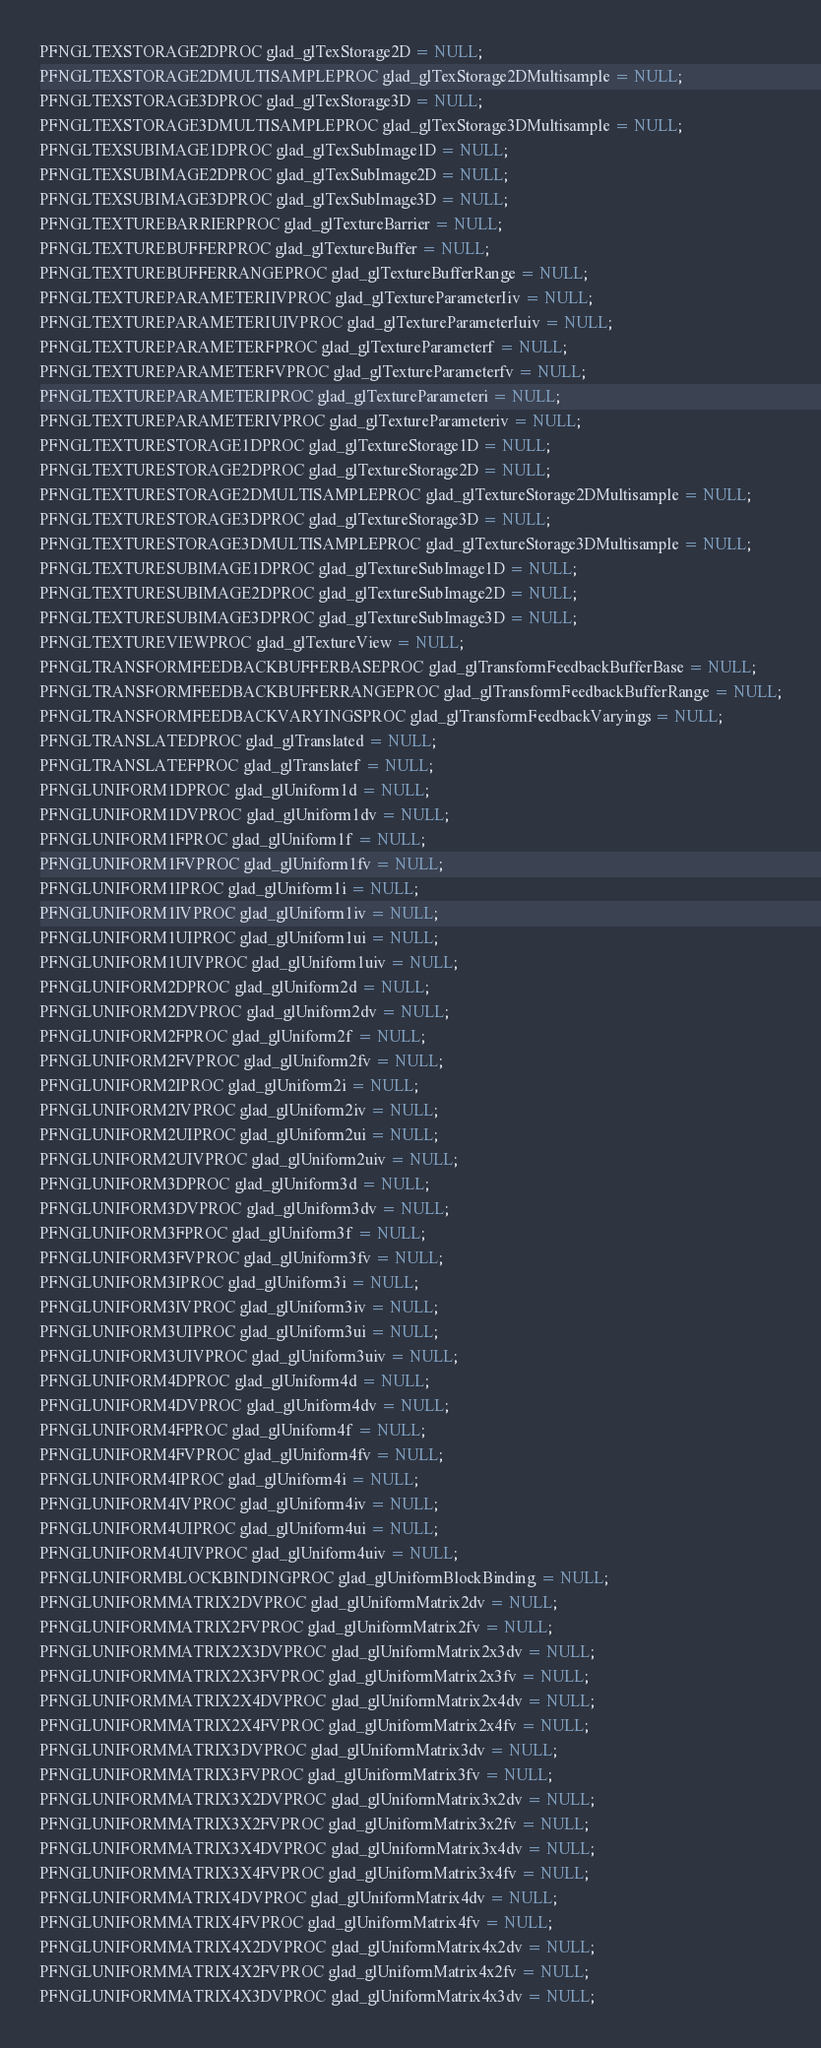<code> <loc_0><loc_0><loc_500><loc_500><_C_>PFNGLTEXSTORAGE2DPROC glad_glTexStorage2D = NULL;
PFNGLTEXSTORAGE2DMULTISAMPLEPROC glad_glTexStorage2DMultisample = NULL;
PFNGLTEXSTORAGE3DPROC glad_glTexStorage3D = NULL;
PFNGLTEXSTORAGE3DMULTISAMPLEPROC glad_glTexStorage3DMultisample = NULL;
PFNGLTEXSUBIMAGE1DPROC glad_glTexSubImage1D = NULL;
PFNGLTEXSUBIMAGE2DPROC glad_glTexSubImage2D = NULL;
PFNGLTEXSUBIMAGE3DPROC glad_glTexSubImage3D = NULL;
PFNGLTEXTUREBARRIERPROC glad_glTextureBarrier = NULL;
PFNGLTEXTUREBUFFERPROC glad_glTextureBuffer = NULL;
PFNGLTEXTUREBUFFERRANGEPROC glad_glTextureBufferRange = NULL;
PFNGLTEXTUREPARAMETERIIVPROC glad_glTextureParameterIiv = NULL;
PFNGLTEXTUREPARAMETERIUIVPROC glad_glTextureParameterIuiv = NULL;
PFNGLTEXTUREPARAMETERFPROC glad_glTextureParameterf = NULL;
PFNGLTEXTUREPARAMETERFVPROC glad_glTextureParameterfv = NULL;
PFNGLTEXTUREPARAMETERIPROC glad_glTextureParameteri = NULL;
PFNGLTEXTUREPARAMETERIVPROC glad_glTextureParameteriv = NULL;
PFNGLTEXTURESTORAGE1DPROC glad_glTextureStorage1D = NULL;
PFNGLTEXTURESTORAGE2DPROC glad_glTextureStorage2D = NULL;
PFNGLTEXTURESTORAGE2DMULTISAMPLEPROC glad_glTextureStorage2DMultisample = NULL;
PFNGLTEXTURESTORAGE3DPROC glad_glTextureStorage3D = NULL;
PFNGLTEXTURESTORAGE3DMULTISAMPLEPROC glad_glTextureStorage3DMultisample = NULL;
PFNGLTEXTURESUBIMAGE1DPROC glad_glTextureSubImage1D = NULL;
PFNGLTEXTURESUBIMAGE2DPROC glad_glTextureSubImage2D = NULL;
PFNGLTEXTURESUBIMAGE3DPROC glad_glTextureSubImage3D = NULL;
PFNGLTEXTUREVIEWPROC glad_glTextureView = NULL;
PFNGLTRANSFORMFEEDBACKBUFFERBASEPROC glad_glTransformFeedbackBufferBase = NULL;
PFNGLTRANSFORMFEEDBACKBUFFERRANGEPROC glad_glTransformFeedbackBufferRange = NULL;
PFNGLTRANSFORMFEEDBACKVARYINGSPROC glad_glTransformFeedbackVaryings = NULL;
PFNGLTRANSLATEDPROC glad_glTranslated = NULL;
PFNGLTRANSLATEFPROC glad_glTranslatef = NULL;
PFNGLUNIFORM1DPROC glad_glUniform1d = NULL;
PFNGLUNIFORM1DVPROC glad_glUniform1dv = NULL;
PFNGLUNIFORM1FPROC glad_glUniform1f = NULL;
PFNGLUNIFORM1FVPROC glad_glUniform1fv = NULL;
PFNGLUNIFORM1IPROC glad_glUniform1i = NULL;
PFNGLUNIFORM1IVPROC glad_glUniform1iv = NULL;
PFNGLUNIFORM1UIPROC glad_glUniform1ui = NULL;
PFNGLUNIFORM1UIVPROC glad_glUniform1uiv = NULL;
PFNGLUNIFORM2DPROC glad_glUniform2d = NULL;
PFNGLUNIFORM2DVPROC glad_glUniform2dv = NULL;
PFNGLUNIFORM2FPROC glad_glUniform2f = NULL;
PFNGLUNIFORM2FVPROC glad_glUniform2fv = NULL;
PFNGLUNIFORM2IPROC glad_glUniform2i = NULL;
PFNGLUNIFORM2IVPROC glad_glUniform2iv = NULL;
PFNGLUNIFORM2UIPROC glad_glUniform2ui = NULL;
PFNGLUNIFORM2UIVPROC glad_glUniform2uiv = NULL;
PFNGLUNIFORM3DPROC glad_glUniform3d = NULL;
PFNGLUNIFORM3DVPROC glad_glUniform3dv = NULL;
PFNGLUNIFORM3FPROC glad_glUniform3f = NULL;
PFNGLUNIFORM3FVPROC glad_glUniform3fv = NULL;
PFNGLUNIFORM3IPROC glad_glUniform3i = NULL;
PFNGLUNIFORM3IVPROC glad_glUniform3iv = NULL;
PFNGLUNIFORM3UIPROC glad_glUniform3ui = NULL;
PFNGLUNIFORM3UIVPROC glad_glUniform3uiv = NULL;
PFNGLUNIFORM4DPROC glad_glUniform4d = NULL;
PFNGLUNIFORM4DVPROC glad_glUniform4dv = NULL;
PFNGLUNIFORM4FPROC glad_glUniform4f = NULL;
PFNGLUNIFORM4FVPROC glad_glUniform4fv = NULL;
PFNGLUNIFORM4IPROC glad_glUniform4i = NULL;
PFNGLUNIFORM4IVPROC glad_glUniform4iv = NULL;
PFNGLUNIFORM4UIPROC glad_glUniform4ui = NULL;
PFNGLUNIFORM4UIVPROC glad_glUniform4uiv = NULL;
PFNGLUNIFORMBLOCKBINDINGPROC glad_glUniformBlockBinding = NULL;
PFNGLUNIFORMMATRIX2DVPROC glad_glUniformMatrix2dv = NULL;
PFNGLUNIFORMMATRIX2FVPROC glad_glUniformMatrix2fv = NULL;
PFNGLUNIFORMMATRIX2X3DVPROC glad_glUniformMatrix2x3dv = NULL;
PFNGLUNIFORMMATRIX2X3FVPROC glad_glUniformMatrix2x3fv = NULL;
PFNGLUNIFORMMATRIX2X4DVPROC glad_glUniformMatrix2x4dv = NULL;
PFNGLUNIFORMMATRIX2X4FVPROC glad_glUniformMatrix2x4fv = NULL;
PFNGLUNIFORMMATRIX3DVPROC glad_glUniformMatrix3dv = NULL;
PFNGLUNIFORMMATRIX3FVPROC glad_glUniformMatrix3fv = NULL;
PFNGLUNIFORMMATRIX3X2DVPROC glad_glUniformMatrix3x2dv = NULL;
PFNGLUNIFORMMATRIX3X2FVPROC glad_glUniformMatrix3x2fv = NULL;
PFNGLUNIFORMMATRIX3X4DVPROC glad_glUniformMatrix3x4dv = NULL;
PFNGLUNIFORMMATRIX3X4FVPROC glad_glUniformMatrix3x4fv = NULL;
PFNGLUNIFORMMATRIX4DVPROC glad_glUniformMatrix4dv = NULL;
PFNGLUNIFORMMATRIX4FVPROC glad_glUniformMatrix4fv = NULL;
PFNGLUNIFORMMATRIX4X2DVPROC glad_glUniformMatrix4x2dv = NULL;
PFNGLUNIFORMMATRIX4X2FVPROC glad_glUniformMatrix4x2fv = NULL;
PFNGLUNIFORMMATRIX4X3DVPROC glad_glUniformMatrix4x3dv = NULL;</code> 